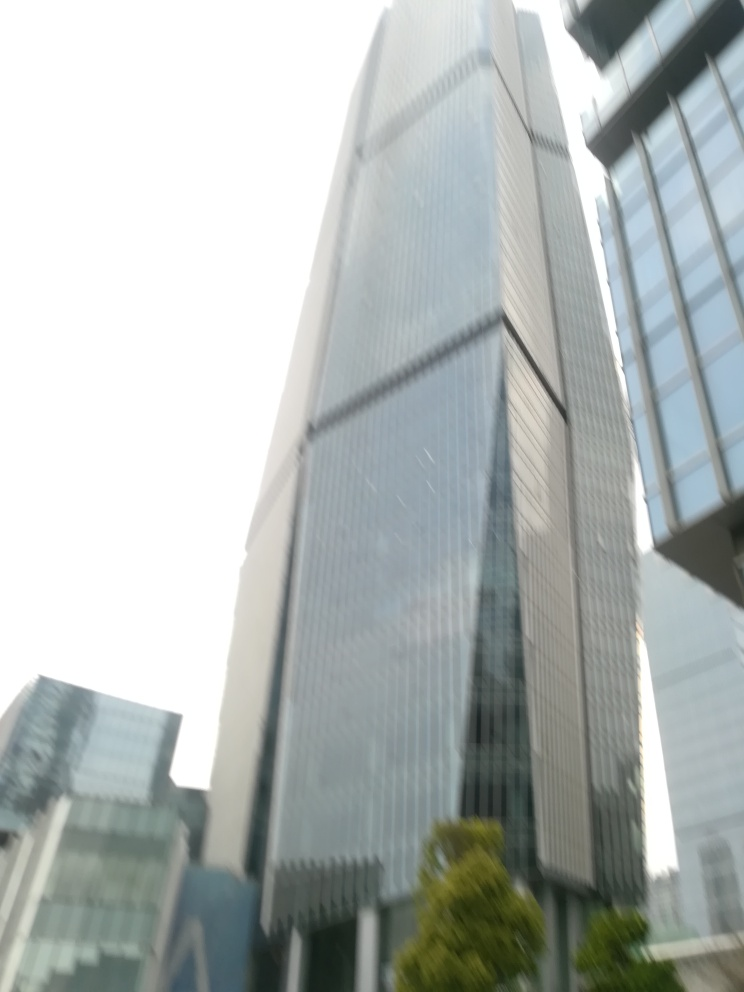How does weather appear to affect the visibility of the building? The overcast sky and possible presence of mist or light rain in the image can result in the building appearing less distinct. These weather conditions tend to soften the outlines of structures and reduce the contrast between the building and its background, leading to a more muted appearance. 